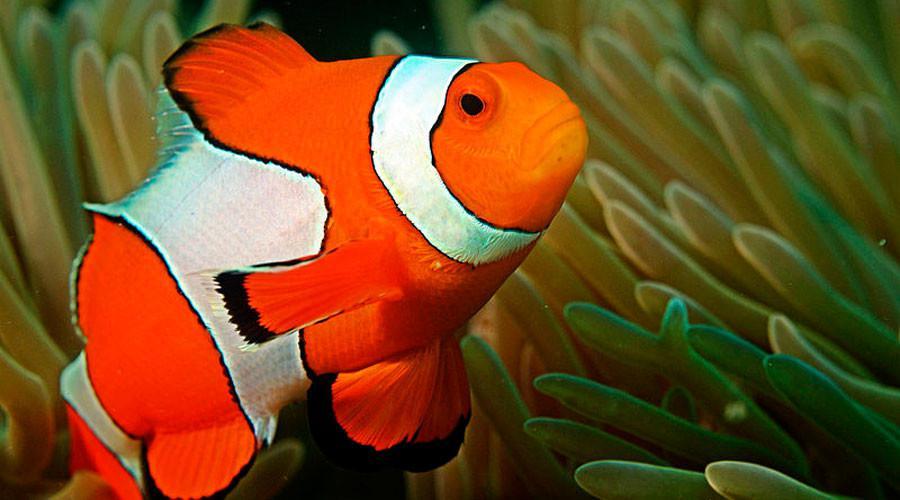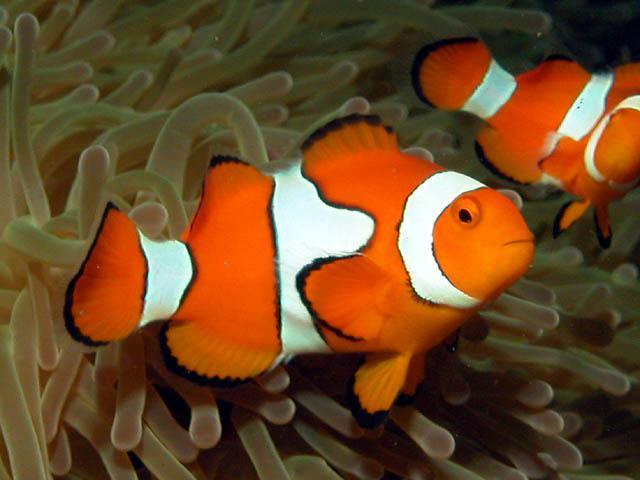The first image is the image on the left, the second image is the image on the right. Given the left and right images, does the statement "At least one image has more than one clown fish." hold true? Answer yes or no. Yes. 